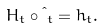<formula> <loc_0><loc_0><loc_500><loc_500>H _ { t } \circ \i _ { t } = h _ { t } .</formula> 